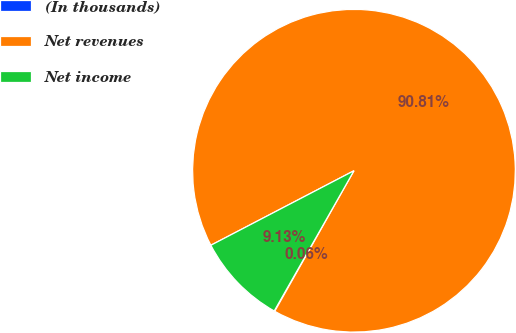Convert chart to OTSL. <chart><loc_0><loc_0><loc_500><loc_500><pie_chart><fcel>(In thousands)<fcel>Net revenues<fcel>Net income<nl><fcel>0.06%<fcel>90.81%<fcel>9.13%<nl></chart> 